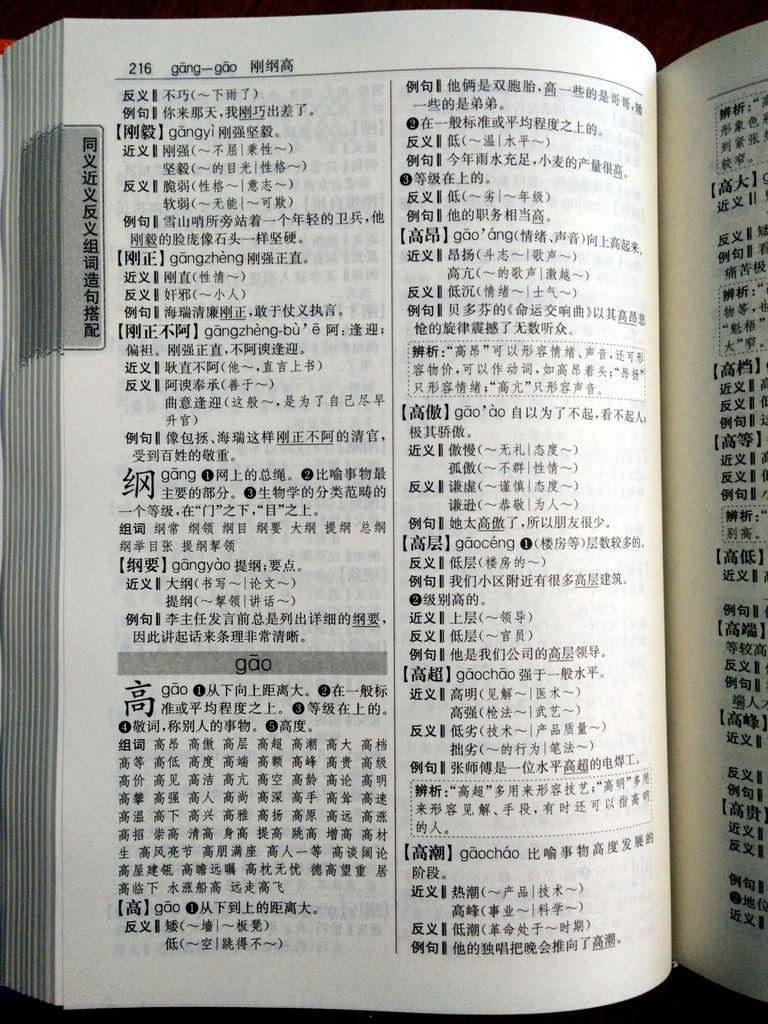<image>
Write a terse but informative summary of the picture. The book is in a foreign language and has been turned to page 216. 